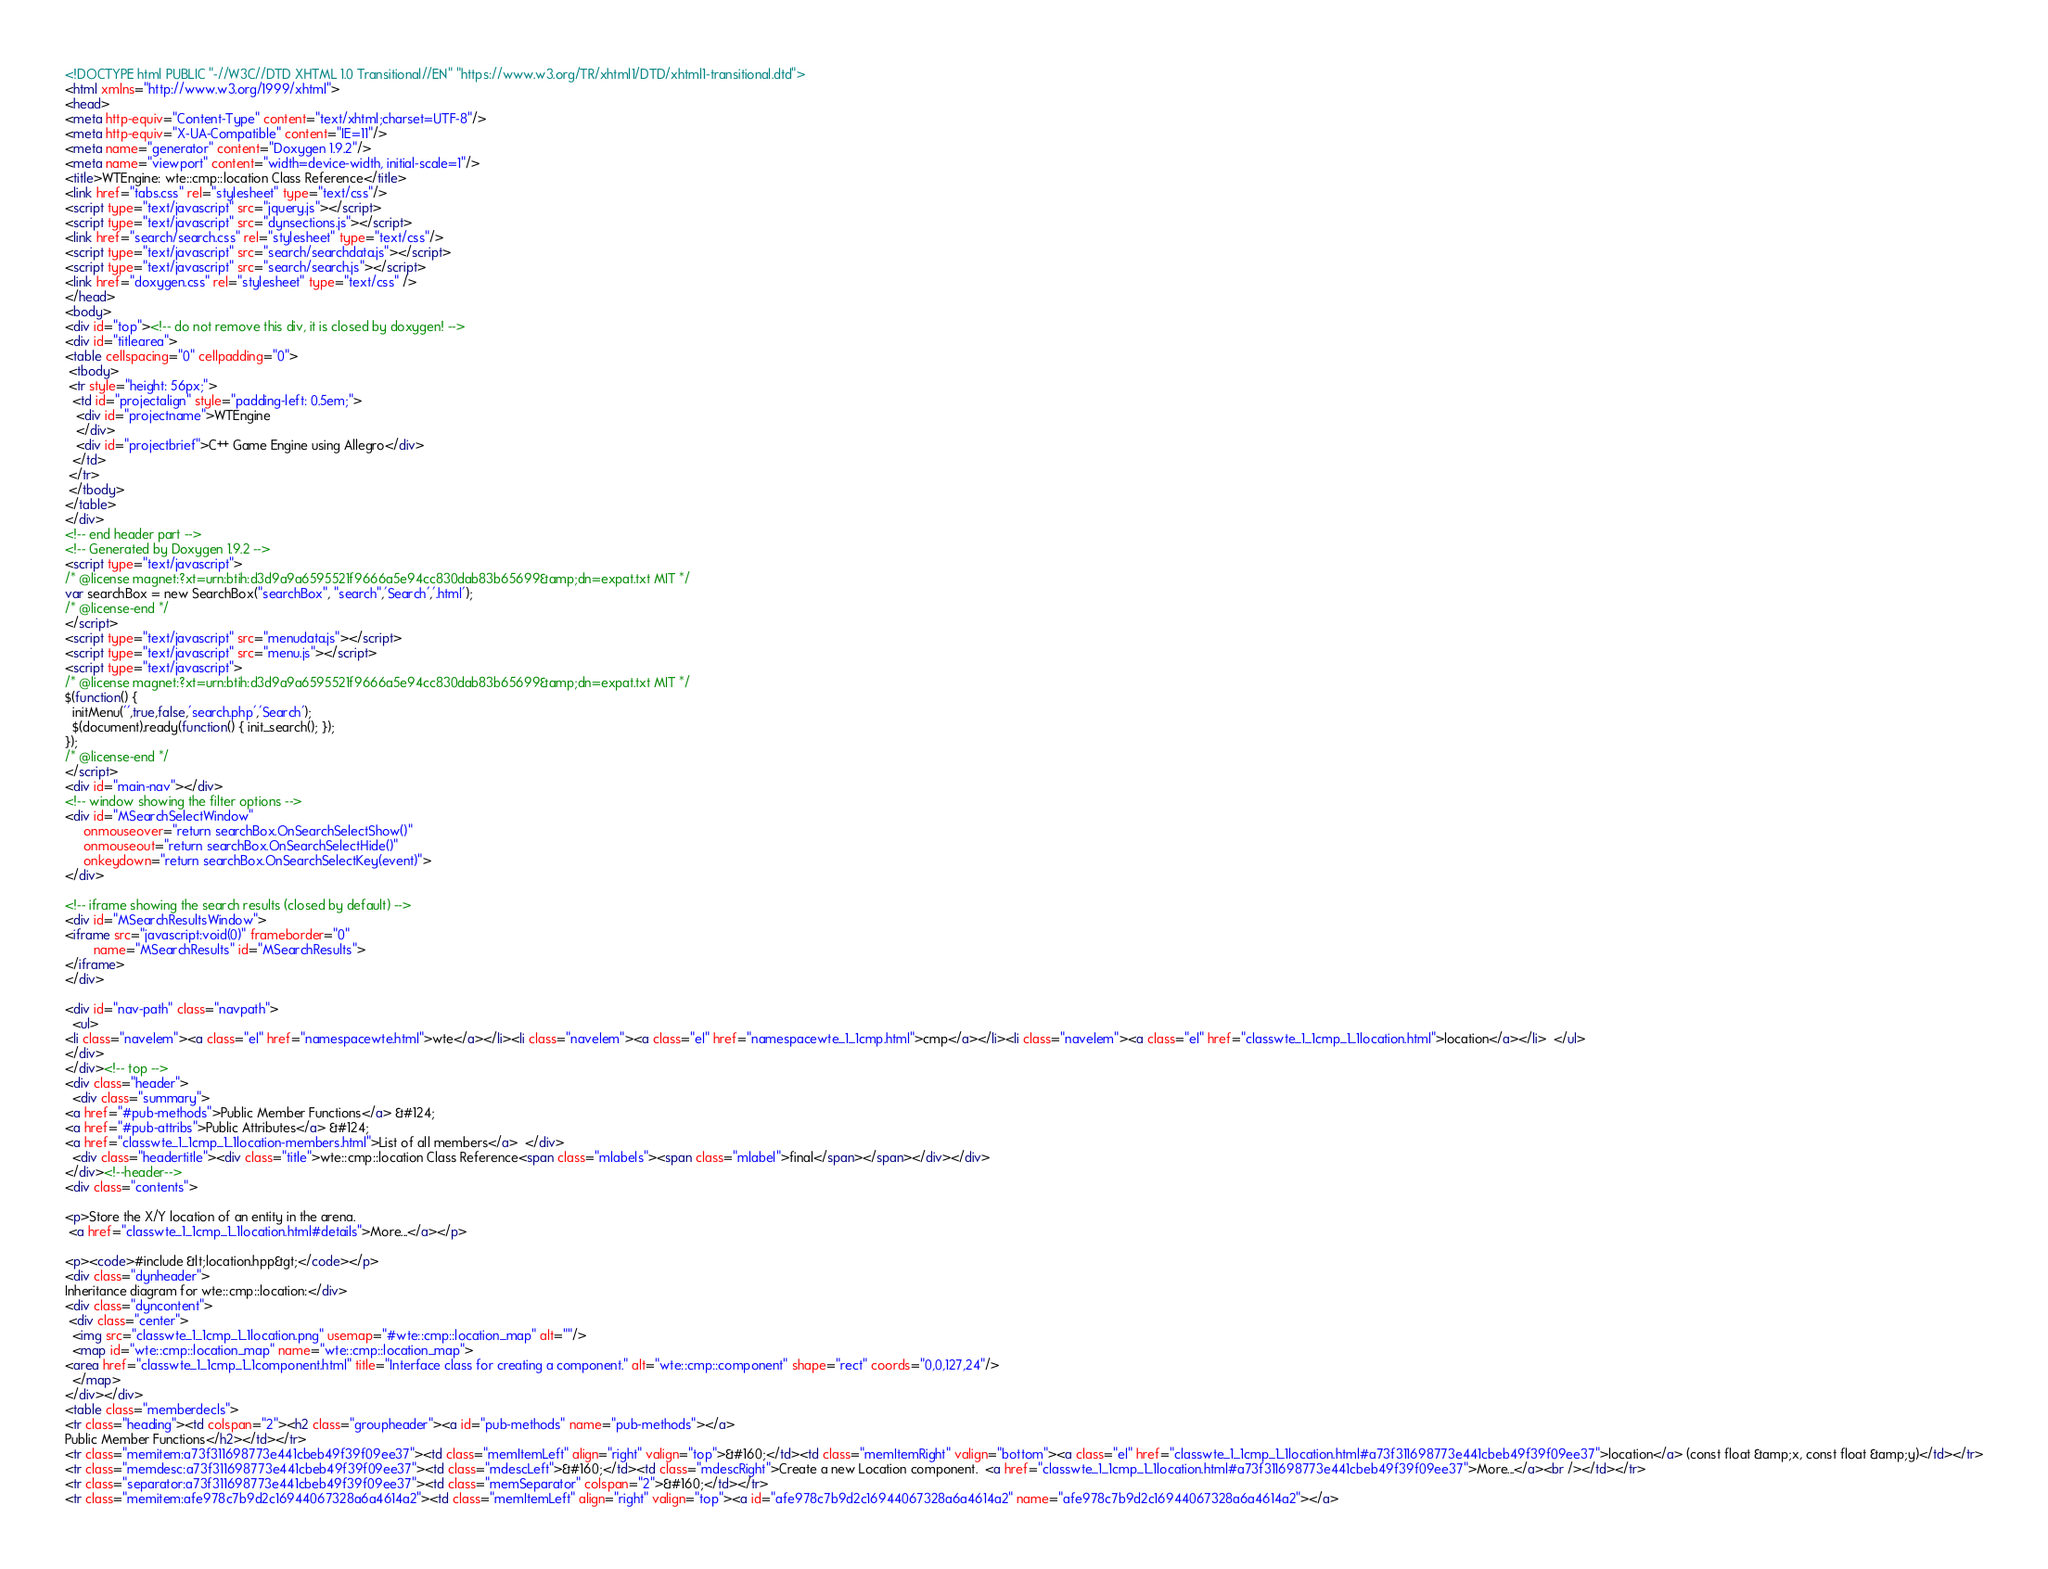<code> <loc_0><loc_0><loc_500><loc_500><_HTML_><!DOCTYPE html PUBLIC "-//W3C//DTD XHTML 1.0 Transitional//EN" "https://www.w3.org/TR/xhtml1/DTD/xhtml1-transitional.dtd">
<html xmlns="http://www.w3.org/1999/xhtml">
<head>
<meta http-equiv="Content-Type" content="text/xhtml;charset=UTF-8"/>
<meta http-equiv="X-UA-Compatible" content="IE=11"/>
<meta name="generator" content="Doxygen 1.9.2"/>
<meta name="viewport" content="width=device-width, initial-scale=1"/>
<title>WTEngine: wte::cmp::location Class Reference</title>
<link href="tabs.css" rel="stylesheet" type="text/css"/>
<script type="text/javascript" src="jquery.js"></script>
<script type="text/javascript" src="dynsections.js"></script>
<link href="search/search.css" rel="stylesheet" type="text/css"/>
<script type="text/javascript" src="search/searchdata.js"></script>
<script type="text/javascript" src="search/search.js"></script>
<link href="doxygen.css" rel="stylesheet" type="text/css" />
</head>
<body>
<div id="top"><!-- do not remove this div, it is closed by doxygen! -->
<div id="titlearea">
<table cellspacing="0" cellpadding="0">
 <tbody>
 <tr style="height: 56px;">
  <td id="projectalign" style="padding-left: 0.5em;">
   <div id="projectname">WTEngine
   </div>
   <div id="projectbrief">C++ Game Engine using Allegro</div>
  </td>
 </tr>
 </tbody>
</table>
</div>
<!-- end header part -->
<!-- Generated by Doxygen 1.9.2 -->
<script type="text/javascript">
/* @license magnet:?xt=urn:btih:d3d9a9a6595521f9666a5e94cc830dab83b65699&amp;dn=expat.txt MIT */
var searchBox = new SearchBox("searchBox", "search",'Search','.html');
/* @license-end */
</script>
<script type="text/javascript" src="menudata.js"></script>
<script type="text/javascript" src="menu.js"></script>
<script type="text/javascript">
/* @license magnet:?xt=urn:btih:d3d9a9a6595521f9666a5e94cc830dab83b65699&amp;dn=expat.txt MIT */
$(function() {
  initMenu('',true,false,'search.php','Search');
  $(document).ready(function() { init_search(); });
});
/* @license-end */
</script>
<div id="main-nav"></div>
<!-- window showing the filter options -->
<div id="MSearchSelectWindow"
     onmouseover="return searchBox.OnSearchSelectShow()"
     onmouseout="return searchBox.OnSearchSelectHide()"
     onkeydown="return searchBox.OnSearchSelectKey(event)">
</div>

<!-- iframe showing the search results (closed by default) -->
<div id="MSearchResultsWindow">
<iframe src="javascript:void(0)" frameborder="0" 
        name="MSearchResults" id="MSearchResults">
</iframe>
</div>

<div id="nav-path" class="navpath">
  <ul>
<li class="navelem"><a class="el" href="namespacewte.html">wte</a></li><li class="navelem"><a class="el" href="namespacewte_1_1cmp.html">cmp</a></li><li class="navelem"><a class="el" href="classwte_1_1cmp_1_1location.html">location</a></li>  </ul>
</div>
</div><!-- top -->
<div class="header">
  <div class="summary">
<a href="#pub-methods">Public Member Functions</a> &#124;
<a href="#pub-attribs">Public Attributes</a> &#124;
<a href="classwte_1_1cmp_1_1location-members.html">List of all members</a>  </div>
  <div class="headertitle"><div class="title">wte::cmp::location Class Reference<span class="mlabels"><span class="mlabel">final</span></span></div></div>
</div><!--header-->
<div class="contents">

<p>Store the X/Y location of an entity in the arena.  
 <a href="classwte_1_1cmp_1_1location.html#details">More...</a></p>

<p><code>#include &lt;location.hpp&gt;</code></p>
<div class="dynheader">
Inheritance diagram for wte::cmp::location:</div>
<div class="dyncontent">
 <div class="center">
  <img src="classwte_1_1cmp_1_1location.png" usemap="#wte::cmp::location_map" alt=""/>
  <map id="wte::cmp::location_map" name="wte::cmp::location_map">
<area href="classwte_1_1cmp_1_1component.html" title="Interface class for creating a component." alt="wte::cmp::component" shape="rect" coords="0,0,127,24"/>
  </map>
</div></div>
<table class="memberdecls">
<tr class="heading"><td colspan="2"><h2 class="groupheader"><a id="pub-methods" name="pub-methods"></a>
Public Member Functions</h2></td></tr>
<tr class="memitem:a73f311698773e441cbeb49f39f09ee37"><td class="memItemLeft" align="right" valign="top">&#160;</td><td class="memItemRight" valign="bottom"><a class="el" href="classwte_1_1cmp_1_1location.html#a73f311698773e441cbeb49f39f09ee37">location</a> (const float &amp;x, const float &amp;y)</td></tr>
<tr class="memdesc:a73f311698773e441cbeb49f39f09ee37"><td class="mdescLeft">&#160;</td><td class="mdescRight">Create a new Location component.  <a href="classwte_1_1cmp_1_1location.html#a73f311698773e441cbeb49f39f09ee37">More...</a><br /></td></tr>
<tr class="separator:a73f311698773e441cbeb49f39f09ee37"><td class="memSeparator" colspan="2">&#160;</td></tr>
<tr class="memitem:afe978c7b9d2c16944067328a6a4614a2"><td class="memItemLeft" align="right" valign="top"><a id="afe978c7b9d2c16944067328a6a4614a2" name="afe978c7b9d2c16944067328a6a4614a2"></a></code> 